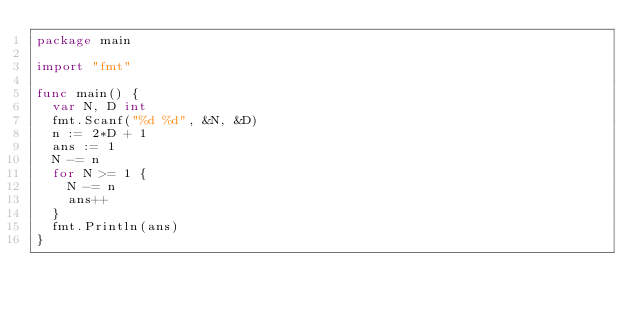Convert code to text. <code><loc_0><loc_0><loc_500><loc_500><_Go_>package main

import "fmt"

func main() {
	var N, D int
	fmt.Scanf("%d %d", &N, &D)
	n := 2*D + 1
	ans := 1
	N -= n
	for N >= 1 {
		N -= n
		ans++
	}
	fmt.Println(ans)
}
</code> 